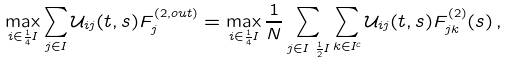Convert formula to latex. <formula><loc_0><loc_0><loc_500><loc_500>\max _ { i \in \frac { 1 } { 4 } I } & \sum _ { j \in I } \mathcal { U } _ { i j } ( t , s ) F _ { j } ^ { ( 2 , o u t ) } = \max _ { i \in \frac { 1 } { 4 } I } \frac { 1 } { N } \sum _ { j \in I \ \frac { 1 } { 2 } I } \sum _ { k \in I ^ { c } } \mathcal { U } _ { i j } ( t , s ) F ^ { ( 2 ) } _ { j k } ( s ) \, ,</formula> 